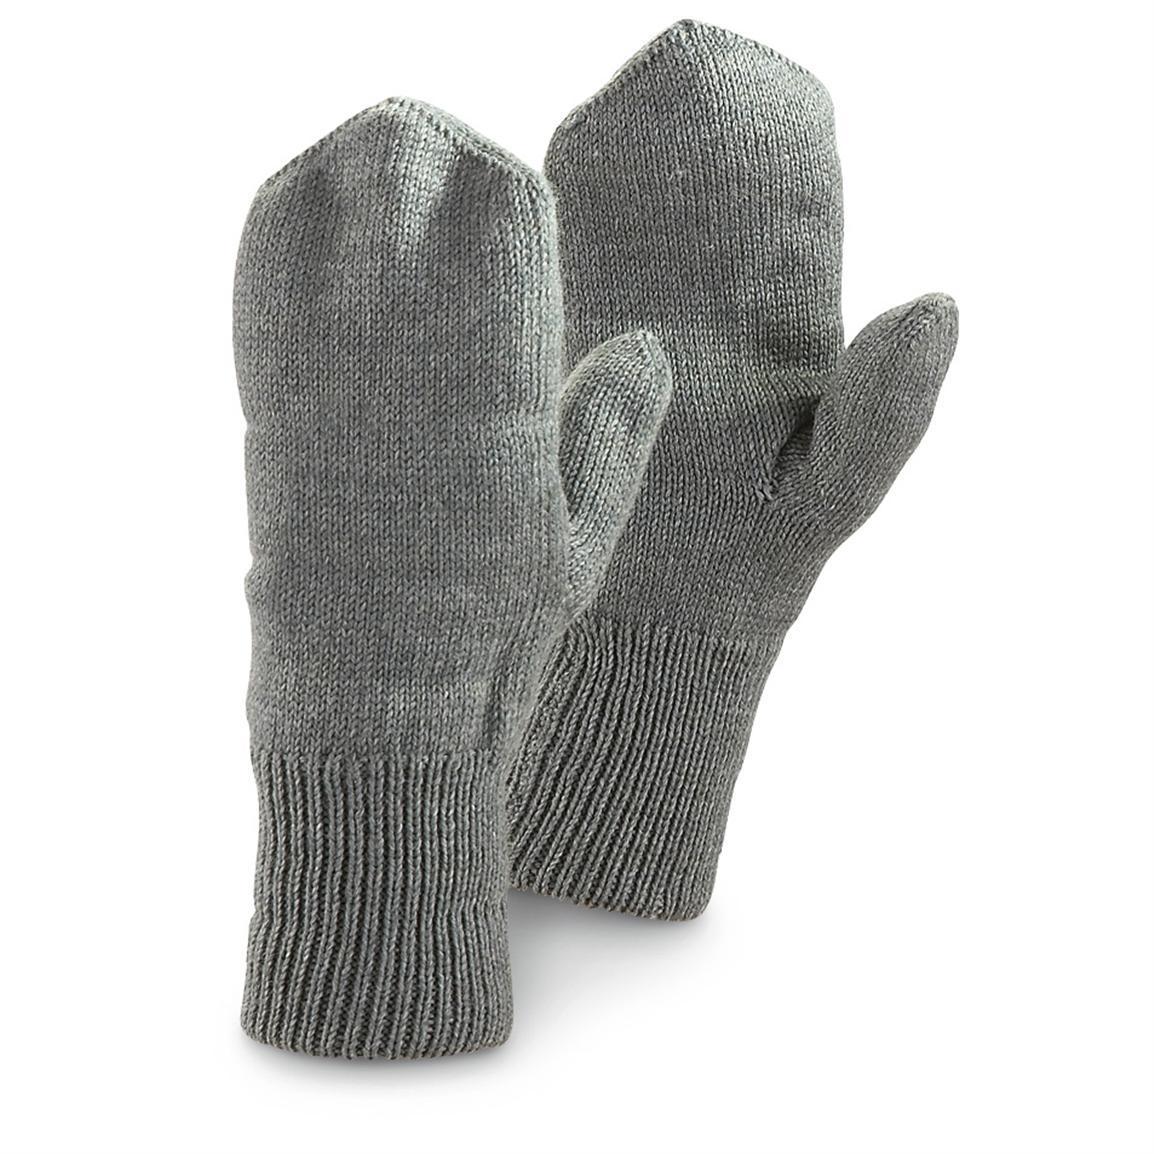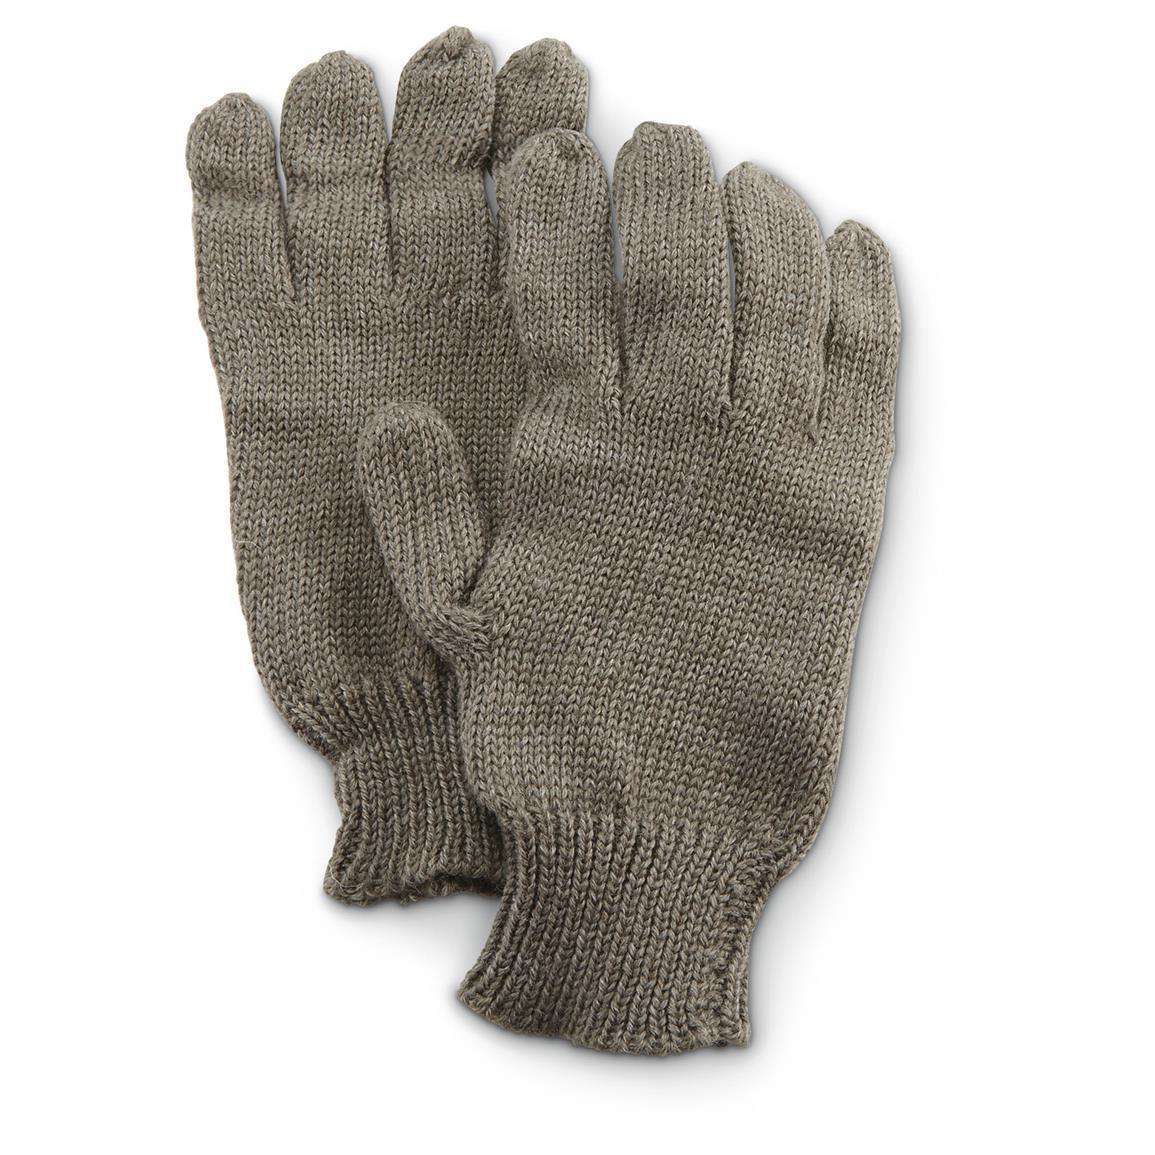The first image is the image on the left, the second image is the image on the right. Considering the images on both sides, is "An image includes a brown knitted hybrid of a mitten and a glove." valid? Answer yes or no. No. 